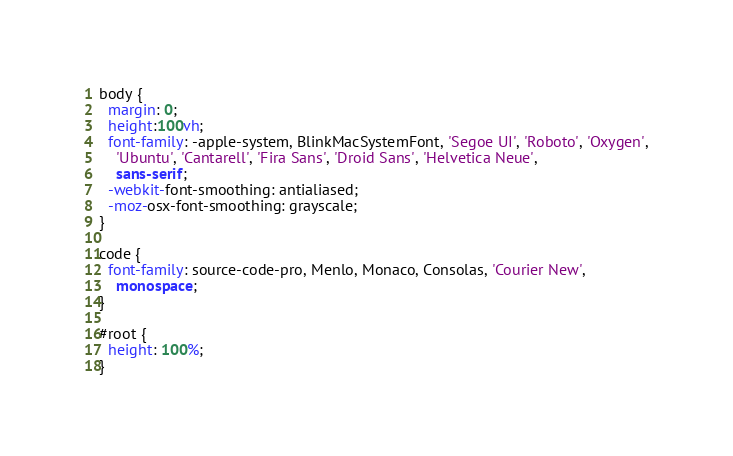Convert code to text. <code><loc_0><loc_0><loc_500><loc_500><_CSS_>body {
  margin: 0;
  height:100vh;
  font-family: -apple-system, BlinkMacSystemFont, 'Segoe UI', 'Roboto', 'Oxygen',
    'Ubuntu', 'Cantarell', 'Fira Sans', 'Droid Sans', 'Helvetica Neue',
    sans-serif;
  -webkit-font-smoothing: antialiased;
  -moz-osx-font-smoothing: grayscale;
}

code {
  font-family: source-code-pro, Menlo, Monaco, Consolas, 'Courier New',
    monospace;
}

#root {
  height: 100%;
}</code> 